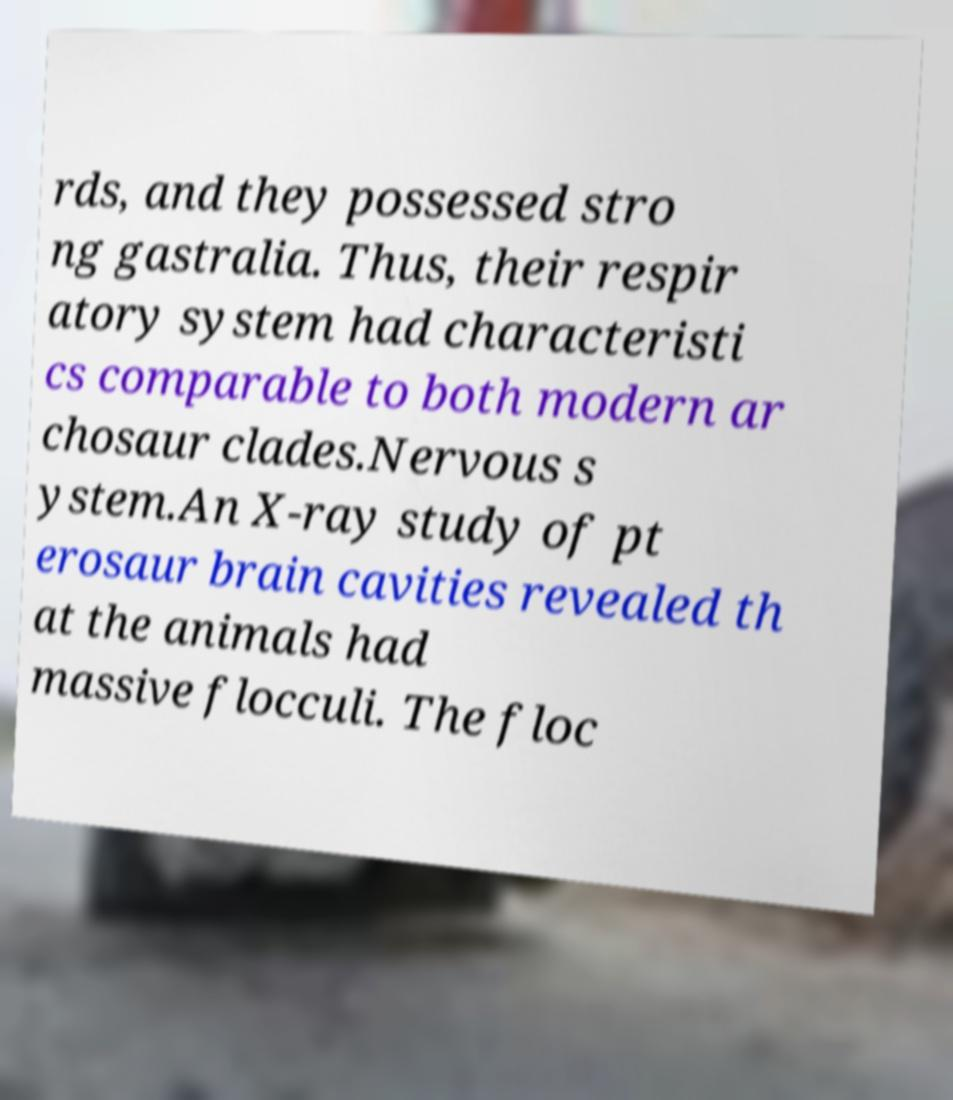Please identify and transcribe the text found in this image. rds, and they possessed stro ng gastralia. Thus, their respir atory system had characteristi cs comparable to both modern ar chosaur clades.Nervous s ystem.An X-ray study of pt erosaur brain cavities revealed th at the animals had massive flocculi. The floc 